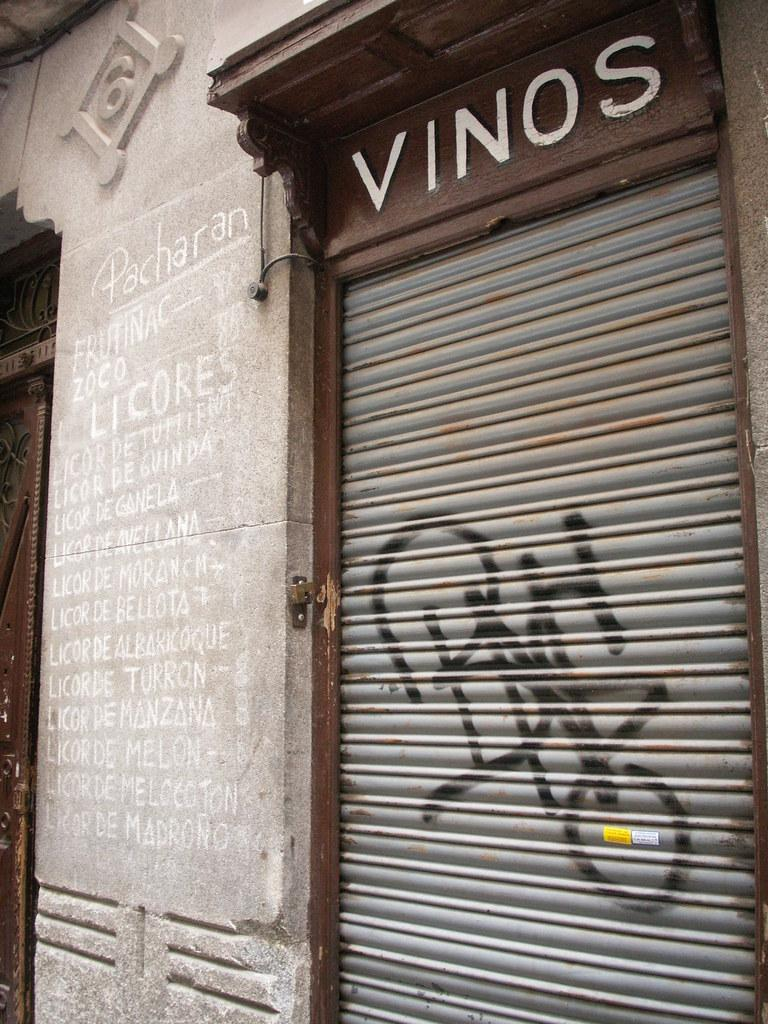What can be seen on the right side of the image? There is a shatter on the right side of the image. What is located near the shatter? There is a wall beside the shatter. Who is the owner of the shattered object in the image? There is no information about the ownership of the shattered object in the image. What type of root can be seen growing through the shatter in the image? There is no root visible in the image; it only shows a shatter and a wall. 